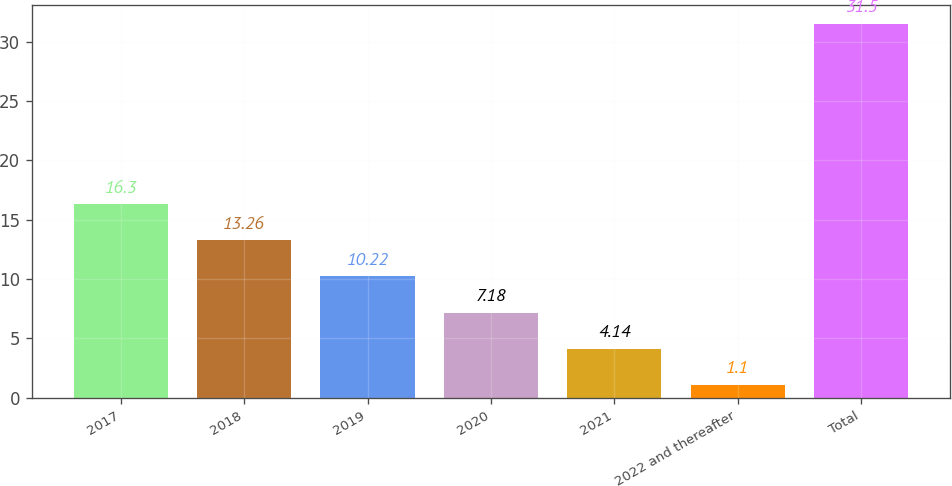Convert chart. <chart><loc_0><loc_0><loc_500><loc_500><bar_chart><fcel>2017<fcel>2018<fcel>2019<fcel>2020<fcel>2021<fcel>2022 and thereafter<fcel>Total<nl><fcel>16.3<fcel>13.26<fcel>10.22<fcel>7.18<fcel>4.14<fcel>1.1<fcel>31.5<nl></chart> 